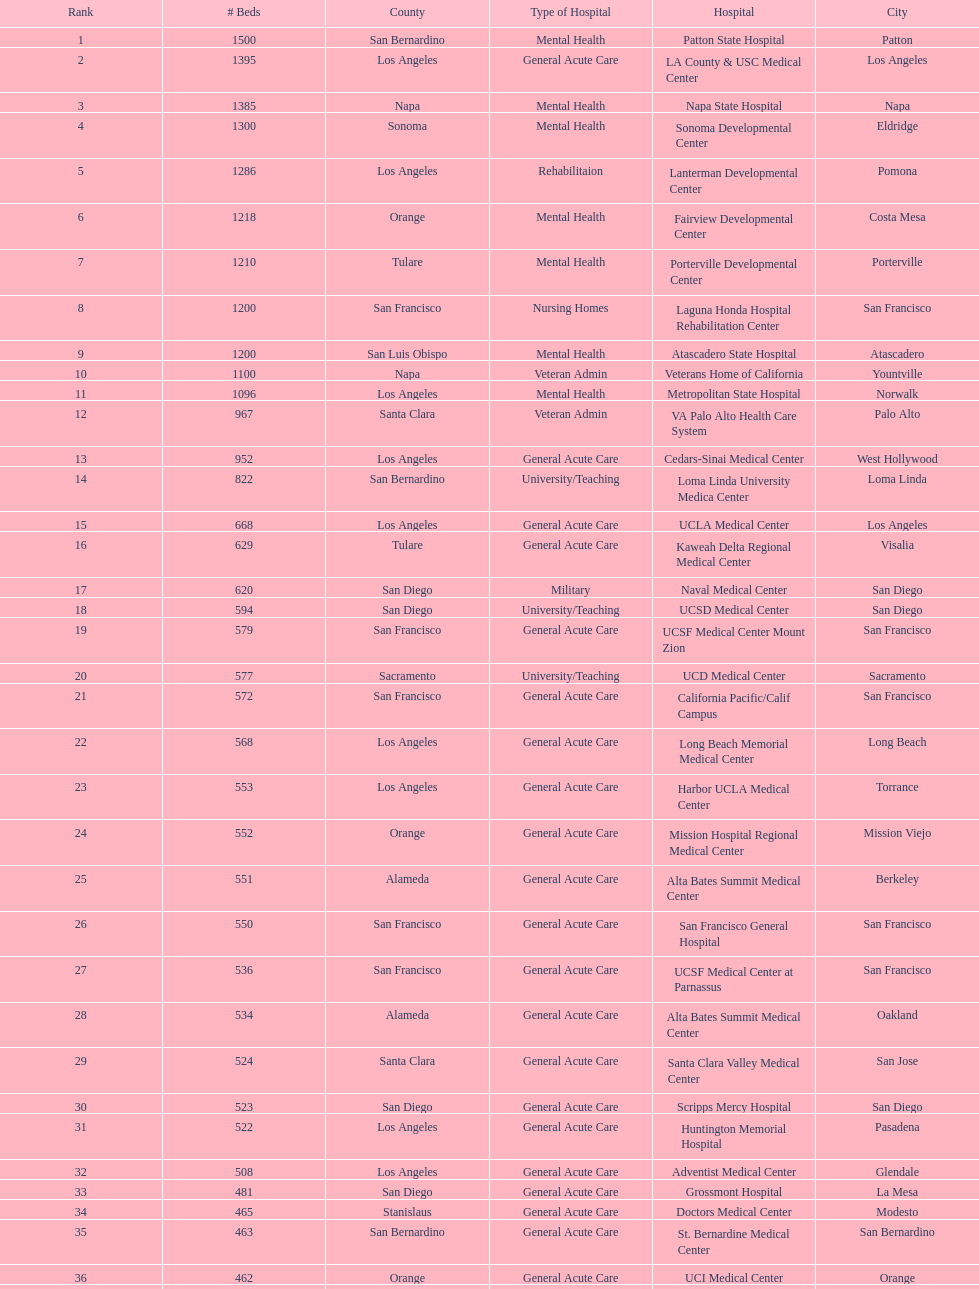How much larger (in number of beds) was the largest hospital in california than the 50th largest? 1071. 